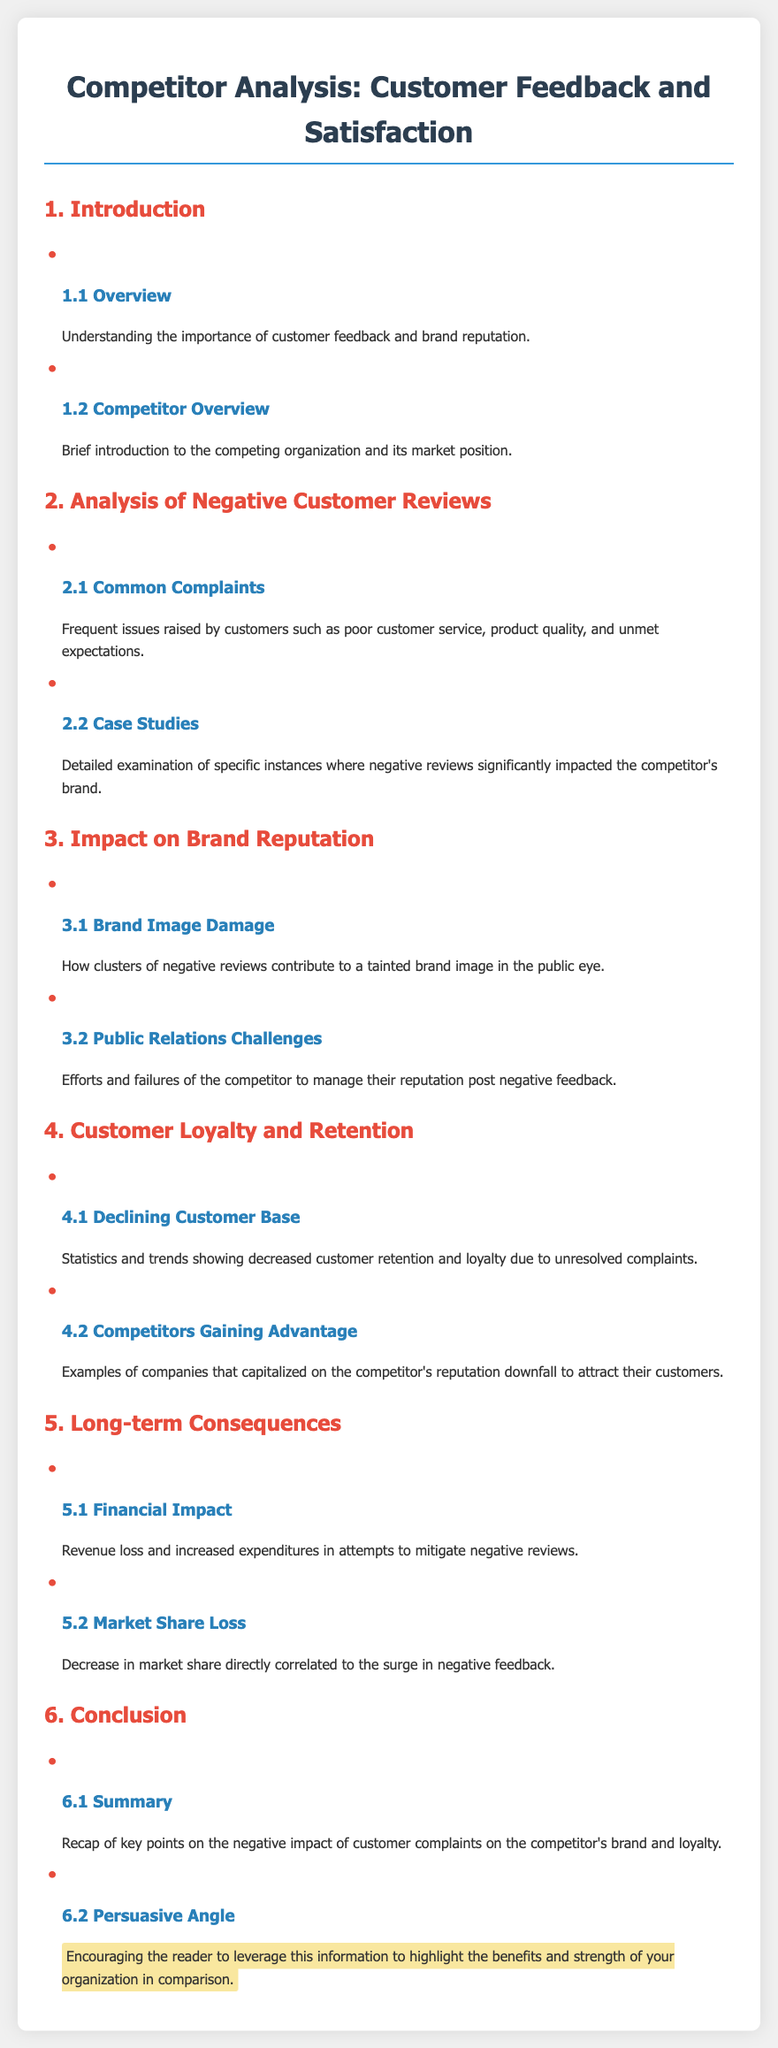What is the title of the document? The title of the document is the main heading presented at the top.
Answer: Competitor Analysis: Customer Feedback and Satisfaction What are the common complaints discussed? The document lists common issues raised by customers in one of its sections.
Answer: Poor customer service, product quality, unmet expectations What does Section 3.1 discuss? Section 3.1 is focused on the impact of negative reviews on brand image.
Answer: Brand Image Damage How does negative feedback affect customer loyalty according to Section 4? Section 4 addresses the implications of unresolved complaints on customer loyalty and retention.
Answer: Declining Customer Base What long-term consequence is listed in Section 5.1? Section 5.1 outlines a financial aspect as a consequence of negative customer reviews.
Answer: Financial Impact What is the persuasive angle mentioned in the conclusion? The conclusion section suggests a focus on advantages over the competitor.
Answer: Highlight the benefits and strength of your organization in comparison 